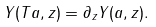Convert formula to latex. <formula><loc_0><loc_0><loc_500><loc_500>Y ( T a , z ) = \partial _ { z } Y ( a , z ) .</formula> 